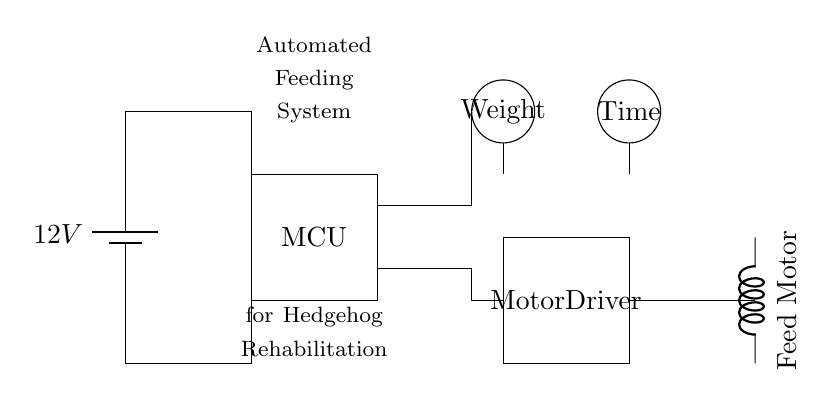What is the battery voltage in this circuit? The voltage of the battery is indicated as 12V, which supplies the power for the circuit.
Answer: 12V What components are used for sensing in this circuit? The circuit has two sensors labeled as Weight and Time, indicating their functions for monitoring in the automated feeding system.
Answer: Weight and Time What does the box labeled "MCU" represent? The box marked as MCU stands for Microcontroller Unit, which is responsible for processing data from sensors and controlling the motor driver based on that data.
Answer: Microcontroller Unit How many connections lead to the motor? There is one connection leading to the motor, indicated by the line connecting the motor driver to the feed motor.
Answer: One What is the purpose of the motor driver in this circuit? The motor driver takes signals from the microcontroller and powers the feed motor, allowing for control over the feeding mechanism based on sensor input.
Answer: To control the feed motor What do the circles labeled "Weight" and "Time" do in the circuit? The circles represent sensors; the Weight sensor measures the food weight while the Time sensor could be used for timing the feeding intervals, helping automate the feeding process.
Answer: Measure food weight and timing How does the microcontroller interact with the sensors and the motor driver? The microcontroller receives inputs from both the Weight and Time sensors and processes this data to send commands to the motor driver, which in turn controls the feed motor, effectively automating the feeding system.
Answer: It processes sensor data and controls the motor driver 